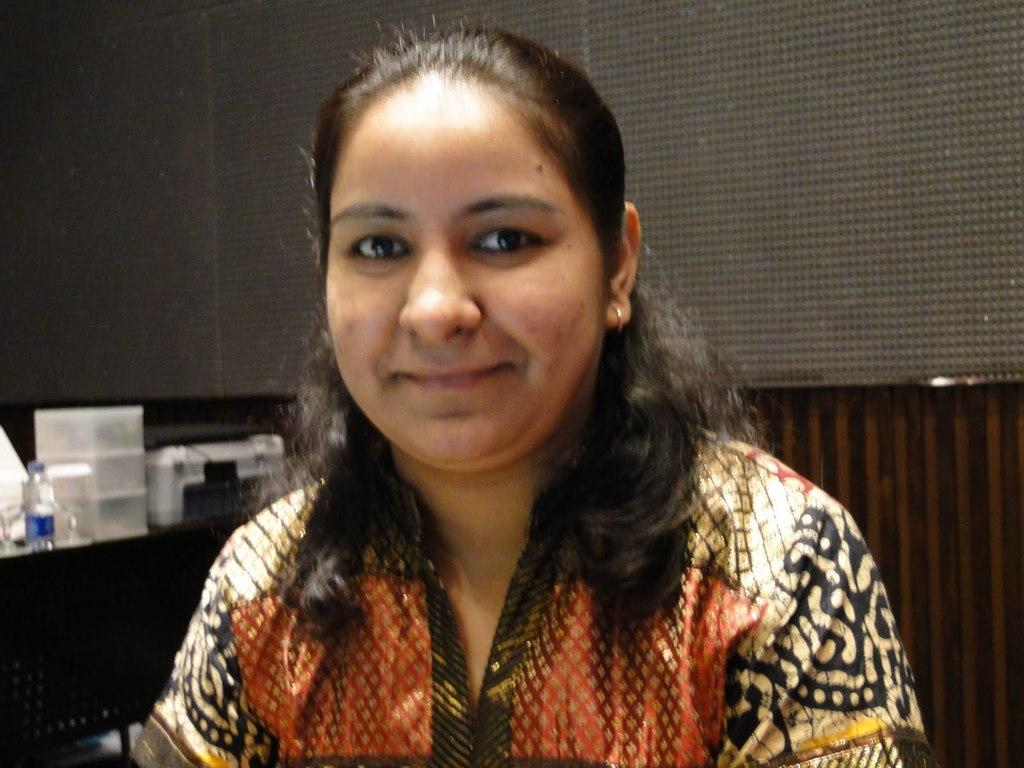Who is present in the image? There is a woman in the image. What can be seen in the background of the image? There is a water bottle and objects on a platform in the background of the image. What type of objects are visible on the platform? The objects on the platform are not specified, but they are present in the image. What else can be seen in the image? There are boards and a wall visible in the image. What type of crown is the woman wearing in the image? There is no crown present in the image; the woman is not wearing any headgear. 